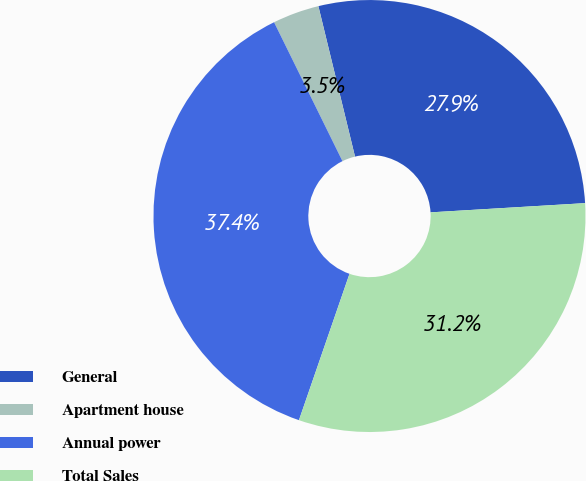<chart> <loc_0><loc_0><loc_500><loc_500><pie_chart><fcel>General<fcel>Apartment house<fcel>Annual power<fcel>Total Sales<nl><fcel>27.85%<fcel>3.48%<fcel>37.42%<fcel>31.24%<nl></chart> 